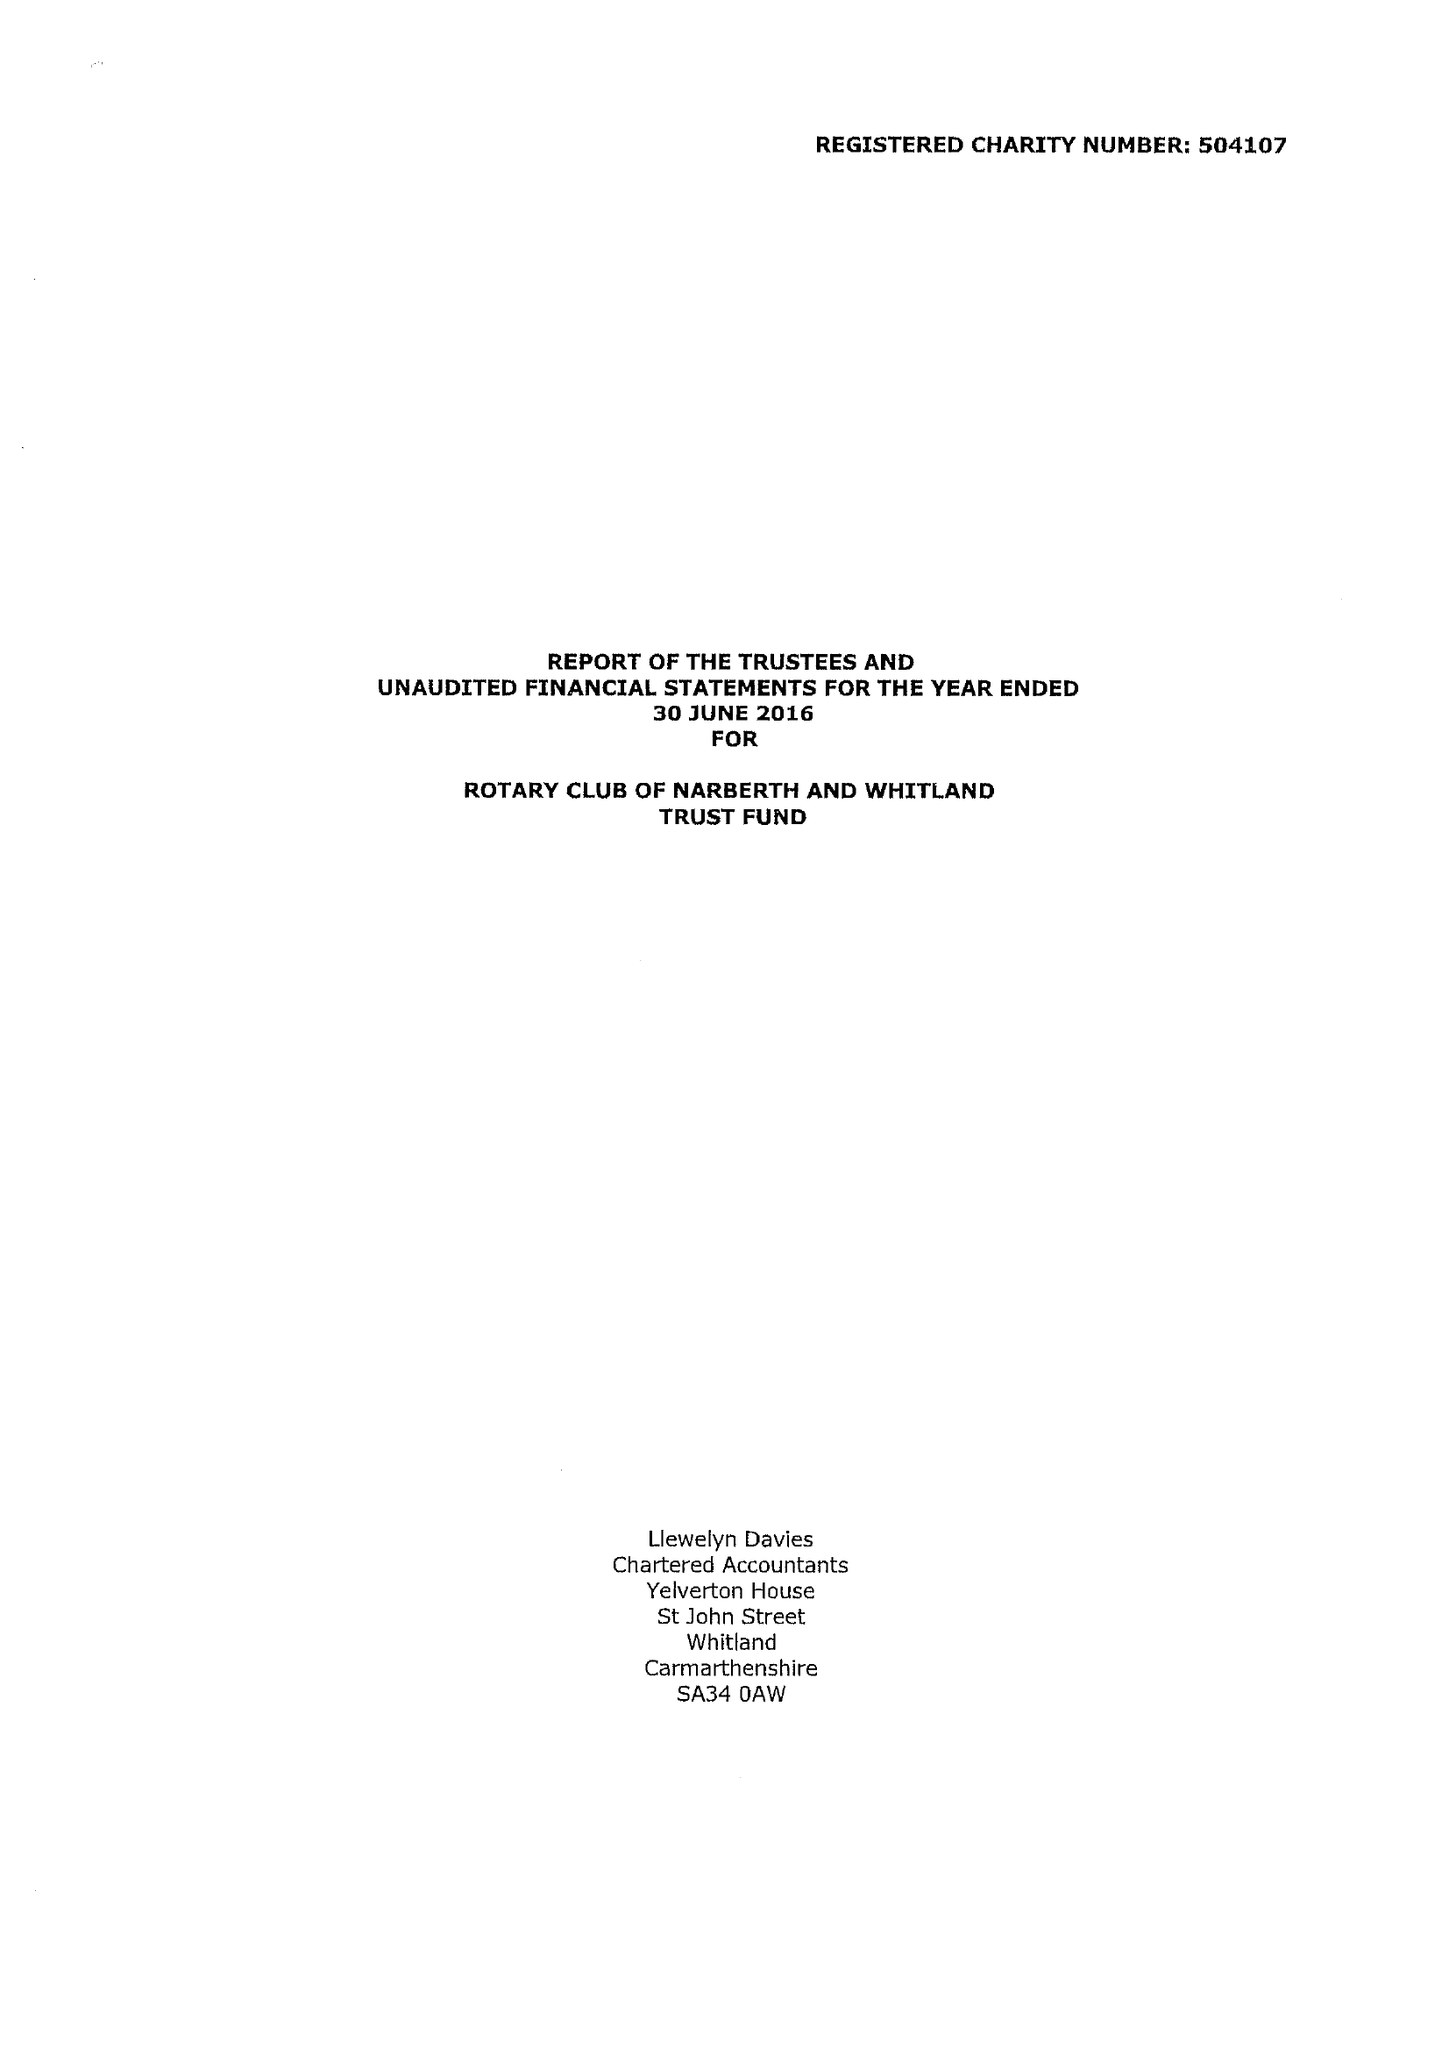What is the value for the charity_name?
Answer the question using a single word or phrase. Rotary Club Of Narberth and Whitland Trust Fund 